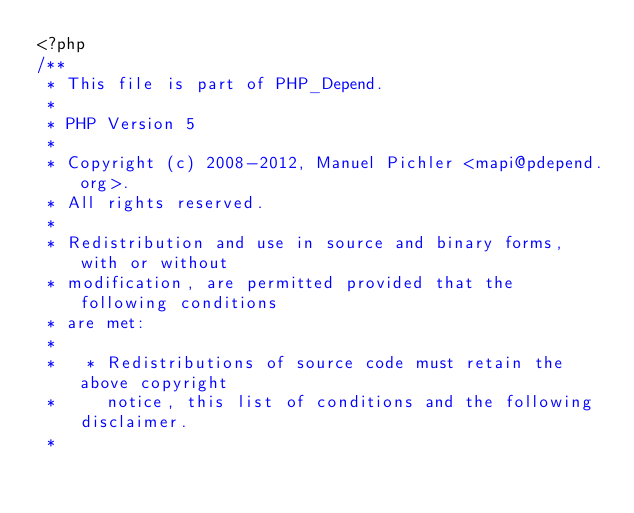<code> <loc_0><loc_0><loc_500><loc_500><_PHP_><?php
/**
 * This file is part of PHP_Depend.
 *
 * PHP Version 5
 *
 * Copyright (c) 2008-2012, Manuel Pichler <mapi@pdepend.org>.
 * All rights reserved.
 *
 * Redistribution and use in source and binary forms, with or without
 * modification, are permitted provided that the following conditions
 * are met:
 *
 *   * Redistributions of source code must retain the above copyright
 *     notice, this list of conditions and the following disclaimer.
 *</code> 